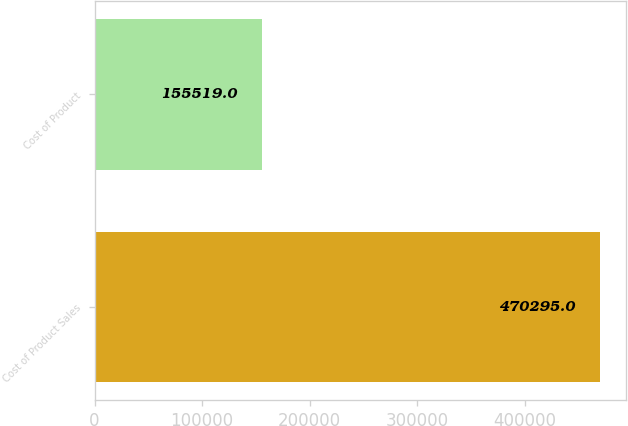<chart> <loc_0><loc_0><loc_500><loc_500><bar_chart><fcel>Cost of Product Sales<fcel>Cost of Product<nl><fcel>470295<fcel>155519<nl></chart> 